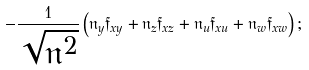<formula> <loc_0><loc_0><loc_500><loc_500>- \frac { 1 } { \sqrt { \mathfrak { n } ^ { 2 } } } \left ( \mathfrak { n } _ { y } \mathfrak { f } _ { x y } + \mathfrak { n } _ { z } \mathfrak { f } _ { x z } + \mathfrak { n } _ { u } \mathfrak { f } _ { x u } + \mathfrak { n } _ { w } \mathfrak { f } _ { x w } \right ) ;</formula> 